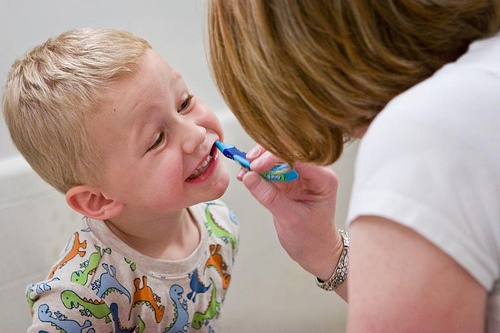Describe the objects in this image and their specific colors. I can see people in lightgray, salmon, maroon, and black tones, people in lightgray, gray, tan, and darkgray tones, and toothbrush in lightgray, teal, brown, and gray tones in this image. 